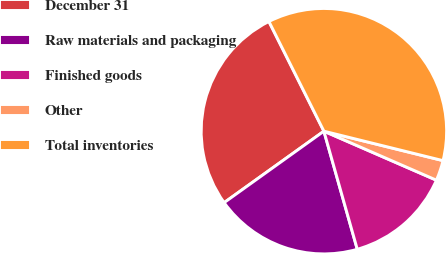Convert chart to OTSL. <chart><loc_0><loc_0><loc_500><loc_500><pie_chart><fcel>December 31<fcel>Raw materials and packaging<fcel>Finished goods<fcel>Other<fcel>Total inventories<nl><fcel>27.5%<fcel>19.49%<fcel>14.08%<fcel>2.68%<fcel>36.25%<nl></chart> 